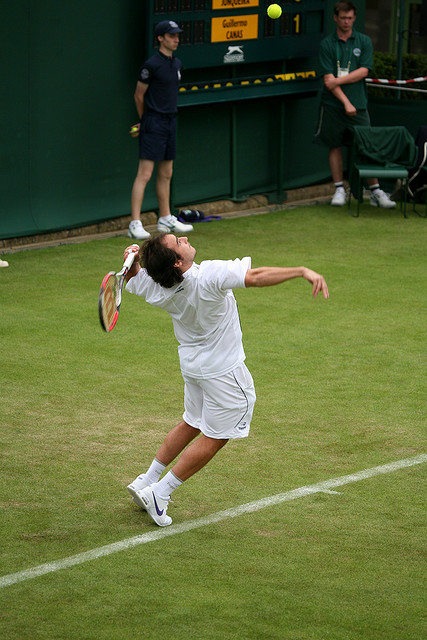Extract all visible text content from this image. 1 